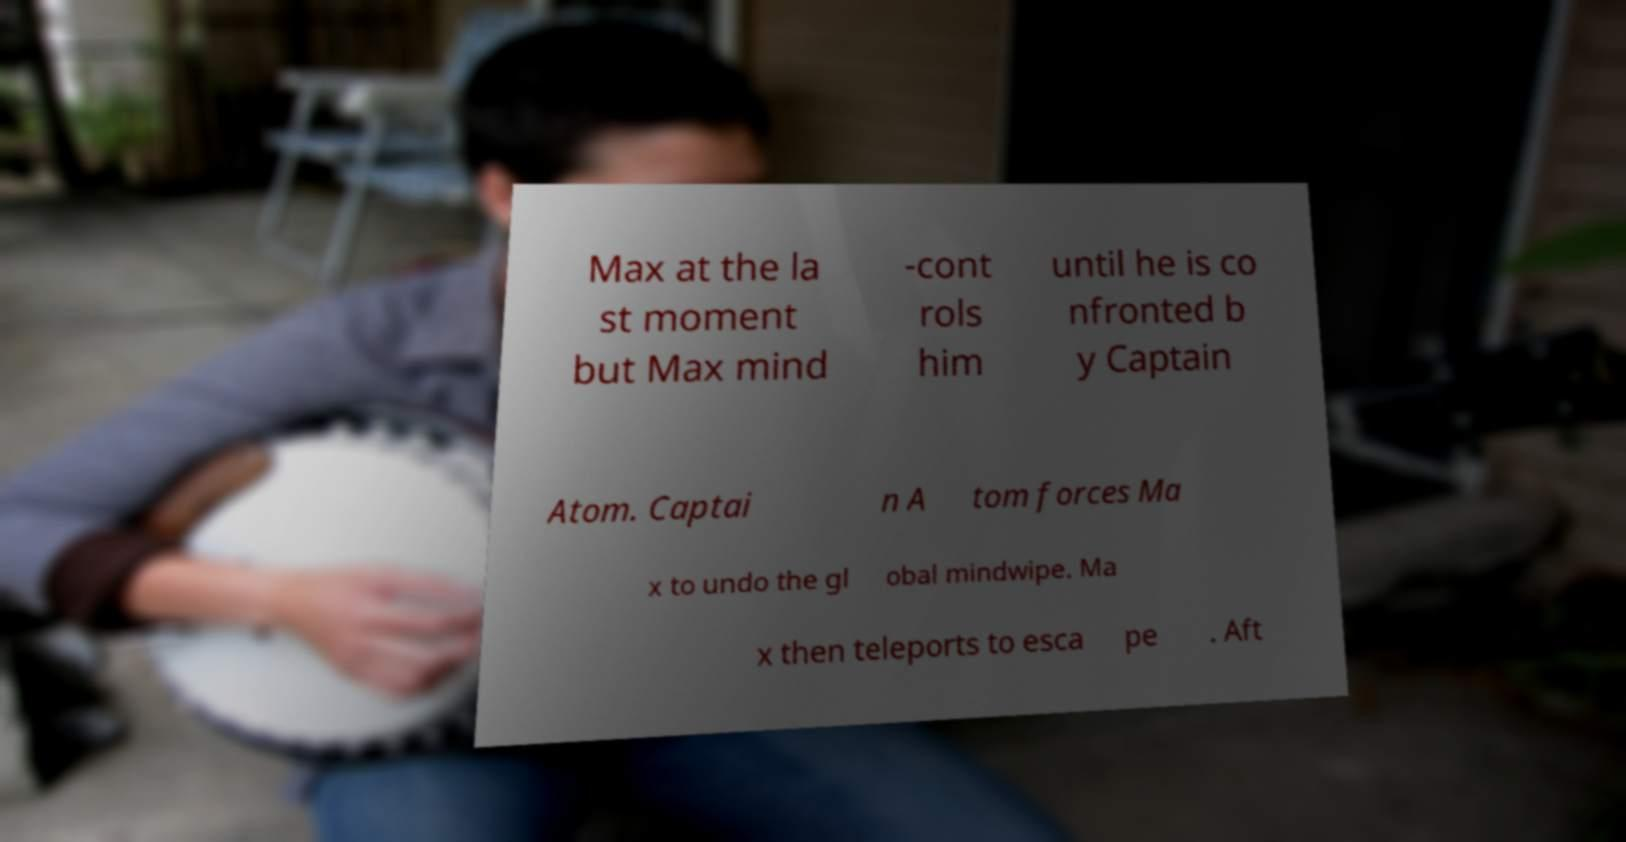What messages or text are displayed in this image? I need them in a readable, typed format. Max at the la st moment but Max mind -cont rols him until he is co nfronted b y Captain Atom. Captai n A tom forces Ma x to undo the gl obal mindwipe. Ma x then teleports to esca pe . Aft 